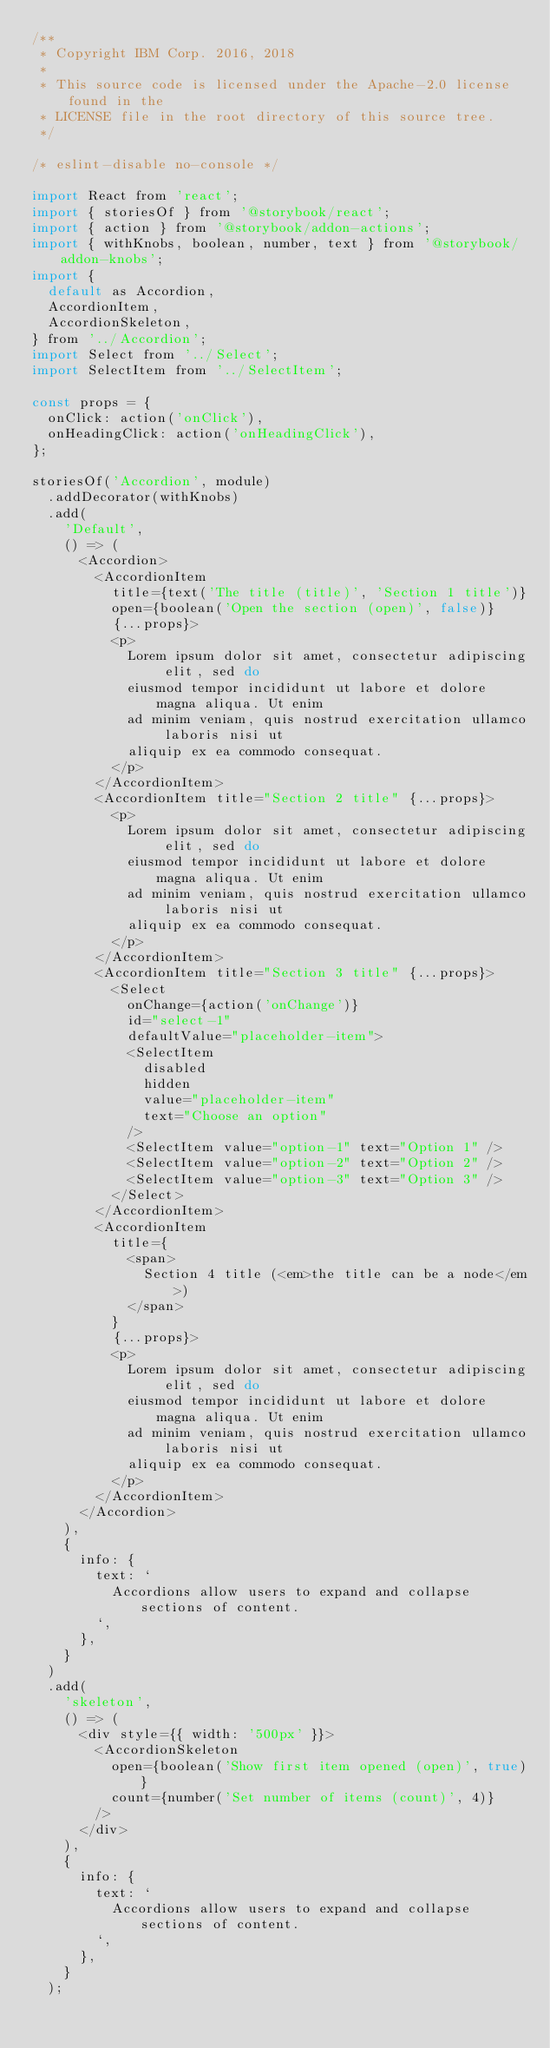<code> <loc_0><loc_0><loc_500><loc_500><_JavaScript_>/**
 * Copyright IBM Corp. 2016, 2018
 *
 * This source code is licensed under the Apache-2.0 license found in the
 * LICENSE file in the root directory of this source tree.
 */

/* eslint-disable no-console */

import React from 'react';
import { storiesOf } from '@storybook/react';
import { action } from '@storybook/addon-actions';
import { withKnobs, boolean, number, text } from '@storybook/addon-knobs';
import {
  default as Accordion,
  AccordionItem,
  AccordionSkeleton,
} from '../Accordion';
import Select from '../Select';
import SelectItem from '../SelectItem';

const props = {
  onClick: action('onClick'),
  onHeadingClick: action('onHeadingClick'),
};

storiesOf('Accordion', module)
  .addDecorator(withKnobs)
  .add(
    'Default',
    () => (
      <Accordion>
        <AccordionItem
          title={text('The title (title)', 'Section 1 title')}
          open={boolean('Open the section (open)', false)}
          {...props}>
          <p>
            Lorem ipsum dolor sit amet, consectetur adipiscing elit, sed do
            eiusmod tempor incididunt ut labore et dolore magna aliqua. Ut enim
            ad minim veniam, quis nostrud exercitation ullamco laboris nisi ut
            aliquip ex ea commodo consequat.
          </p>
        </AccordionItem>
        <AccordionItem title="Section 2 title" {...props}>
          <p>
            Lorem ipsum dolor sit amet, consectetur adipiscing elit, sed do
            eiusmod tempor incididunt ut labore et dolore magna aliqua. Ut enim
            ad minim veniam, quis nostrud exercitation ullamco laboris nisi ut
            aliquip ex ea commodo consequat.
          </p>
        </AccordionItem>
        <AccordionItem title="Section 3 title" {...props}>
          <Select
            onChange={action('onChange')}
            id="select-1"
            defaultValue="placeholder-item">
            <SelectItem
              disabled
              hidden
              value="placeholder-item"
              text="Choose an option"
            />
            <SelectItem value="option-1" text="Option 1" />
            <SelectItem value="option-2" text="Option 2" />
            <SelectItem value="option-3" text="Option 3" />
          </Select>
        </AccordionItem>
        <AccordionItem
          title={
            <span>
              Section 4 title (<em>the title can be a node</em>)
            </span>
          }
          {...props}>
          <p>
            Lorem ipsum dolor sit amet, consectetur adipiscing elit, sed do
            eiusmod tempor incididunt ut labore et dolore magna aliqua. Ut enim
            ad minim veniam, quis nostrud exercitation ullamco laboris nisi ut
            aliquip ex ea commodo consequat.
          </p>
        </AccordionItem>
      </Accordion>
    ),
    {
      info: {
        text: `
          Accordions allow users to expand and collapse sections of content.
        `,
      },
    }
  )
  .add(
    'skeleton',
    () => (
      <div style={{ width: '500px' }}>
        <AccordionSkeleton
          open={boolean('Show first item opened (open)', true)}
          count={number('Set number of items (count)', 4)}
        />
      </div>
    ),
    {
      info: {
        text: `
          Accordions allow users to expand and collapse sections of content.
        `,
      },
    }
  );
</code> 